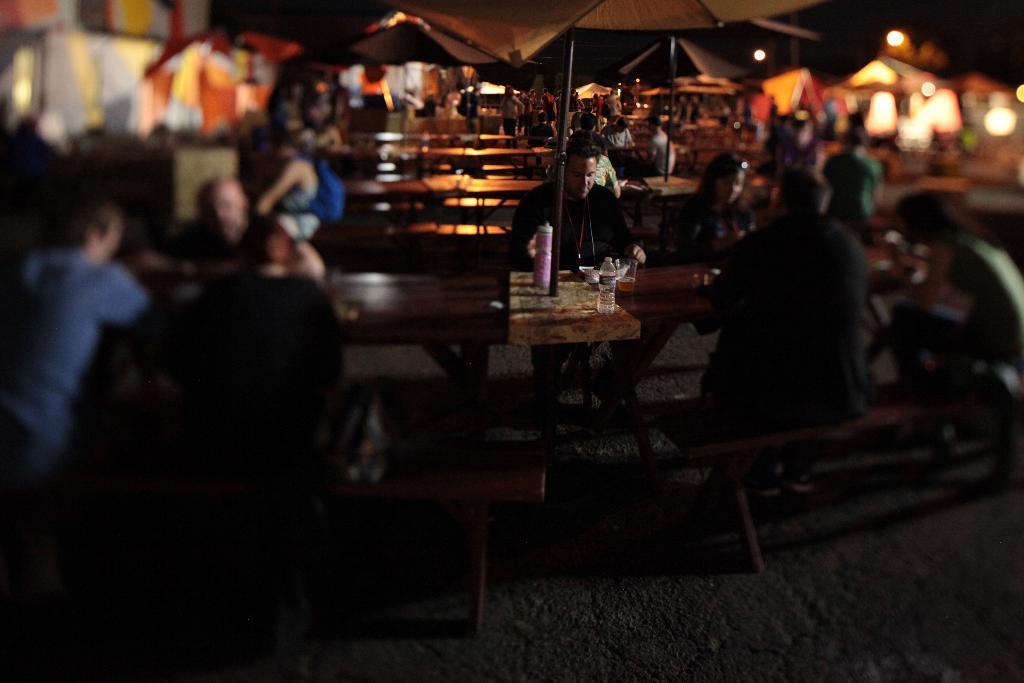Can you describe this image briefly? As we can see in the image, there are a lot of people sitting on benches. On this table there is a bottle and the floor is in brown color. 